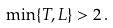Convert formula to latex. <formula><loc_0><loc_0><loc_500><loc_500>\min \{ T , L \} > 2 \, .</formula> 